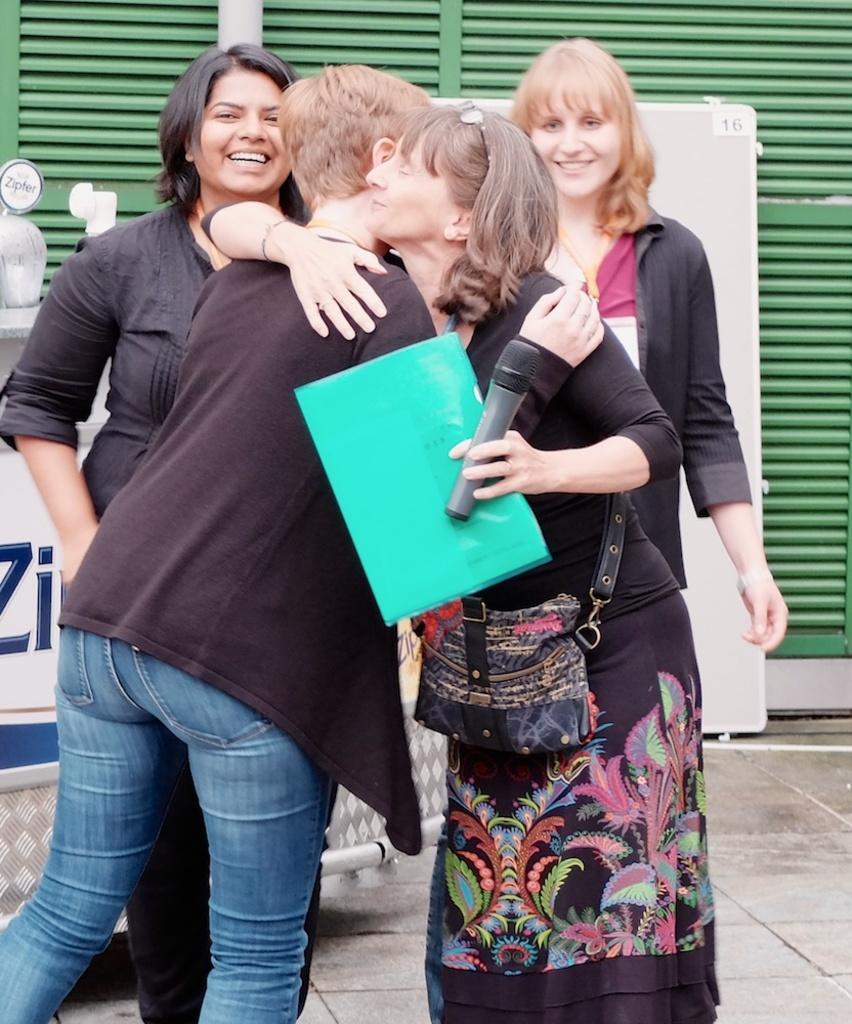Please provide a concise description of this image. In the image there are four women, first two women are hugging each other ,the right side woman wearing black dress is holding mic and file in her and she is wearing a bag to her left hand ,in the background is a green color window. 